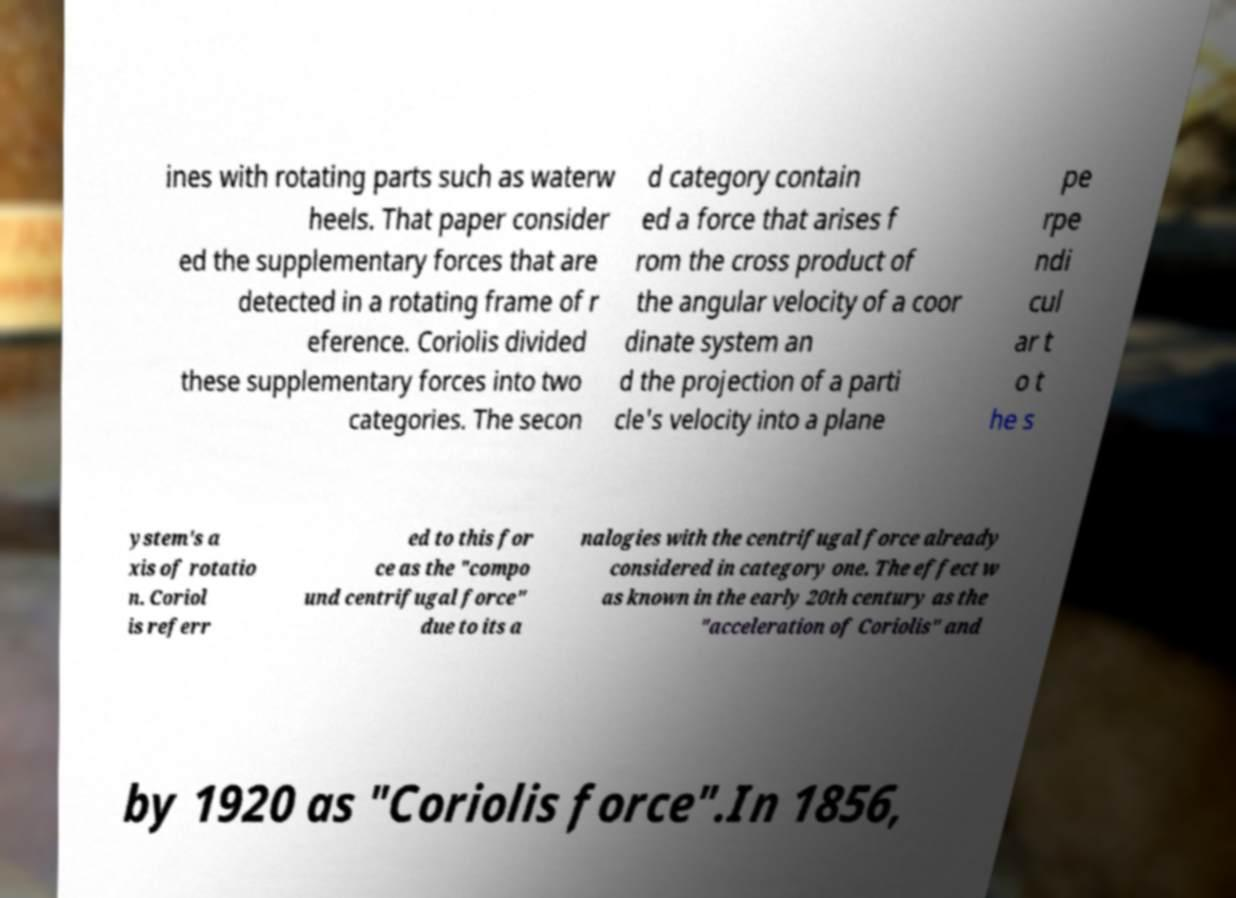Please read and relay the text visible in this image. What does it say? ines with rotating parts such as waterw heels. That paper consider ed the supplementary forces that are detected in a rotating frame of r eference. Coriolis divided these supplementary forces into two categories. The secon d category contain ed a force that arises f rom the cross product of the angular velocity of a coor dinate system an d the projection of a parti cle's velocity into a plane pe rpe ndi cul ar t o t he s ystem's a xis of rotatio n. Coriol is referr ed to this for ce as the "compo und centrifugal force" due to its a nalogies with the centrifugal force already considered in category one. The effect w as known in the early 20th century as the "acceleration of Coriolis" and by 1920 as "Coriolis force".In 1856, 